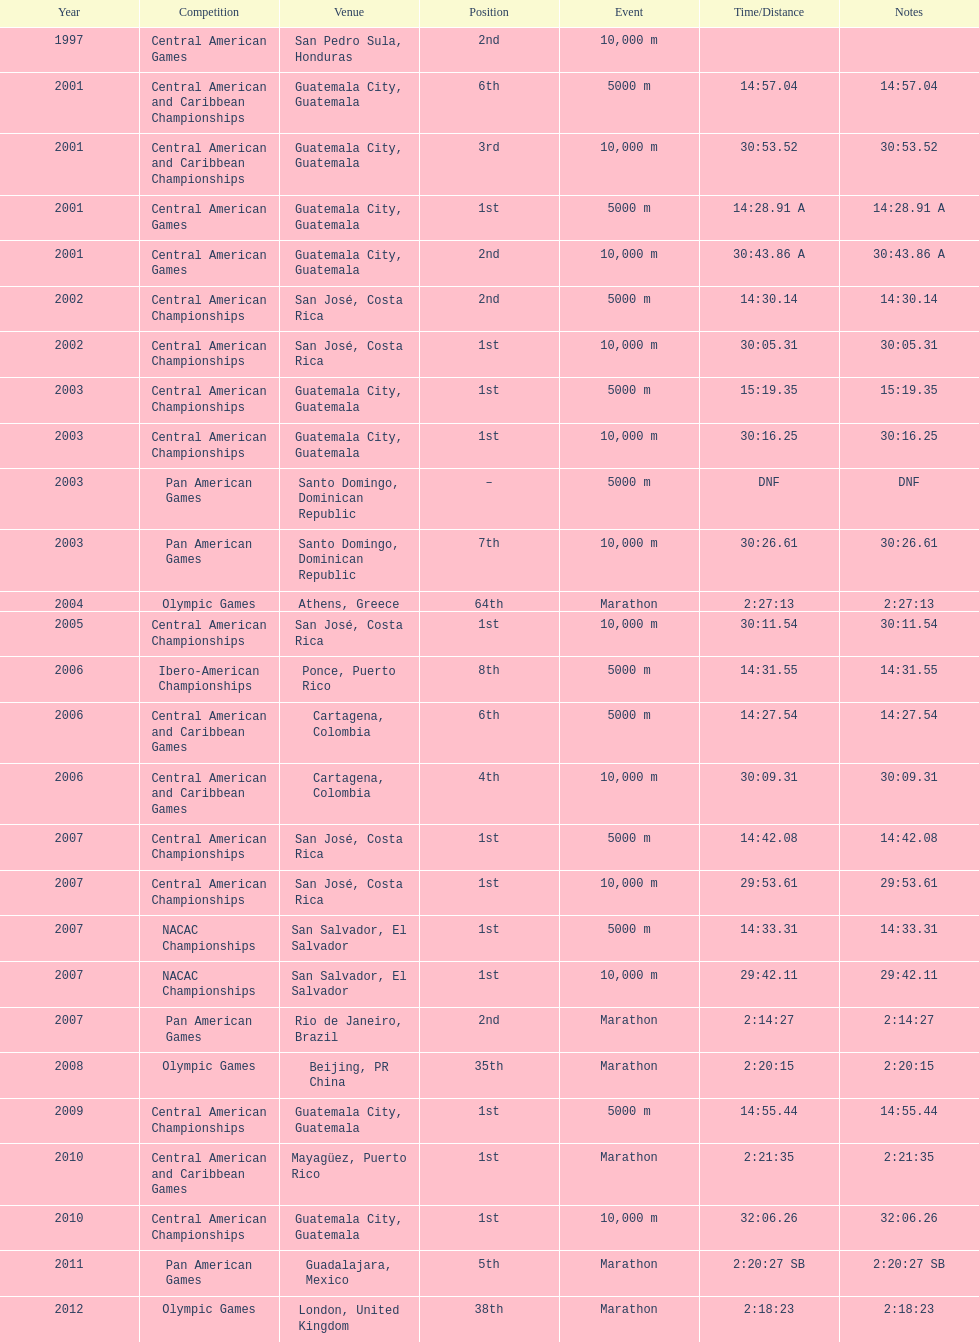What was the last competition in which a position of "2nd" was achieved? Pan American Games. 